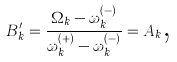Convert formula to latex. <formula><loc_0><loc_0><loc_500><loc_500>B _ { k } ^ { \prime } = \frac { \Omega _ { k } - \omega _ { k } ^ { ( - ) } } { \omega _ { k } ^ { ( + ) } - \omega _ { k } ^ { ( - ) } } = A _ { k } \text {,}</formula> 